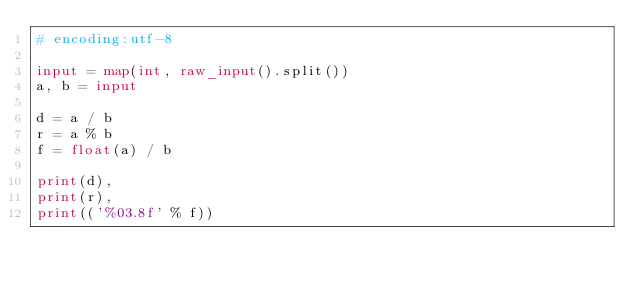Convert code to text. <code><loc_0><loc_0><loc_500><loc_500><_Python_># encoding:utf-8

input = map(int, raw_input().split())
a, b = input

d = a / b
r = a % b
f = float(a) / b

print(d),
print(r),
print(('%03.8f' % f))</code> 